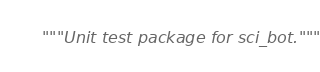<code> <loc_0><loc_0><loc_500><loc_500><_Python_>
"""Unit test package for sci_bot."""
</code> 